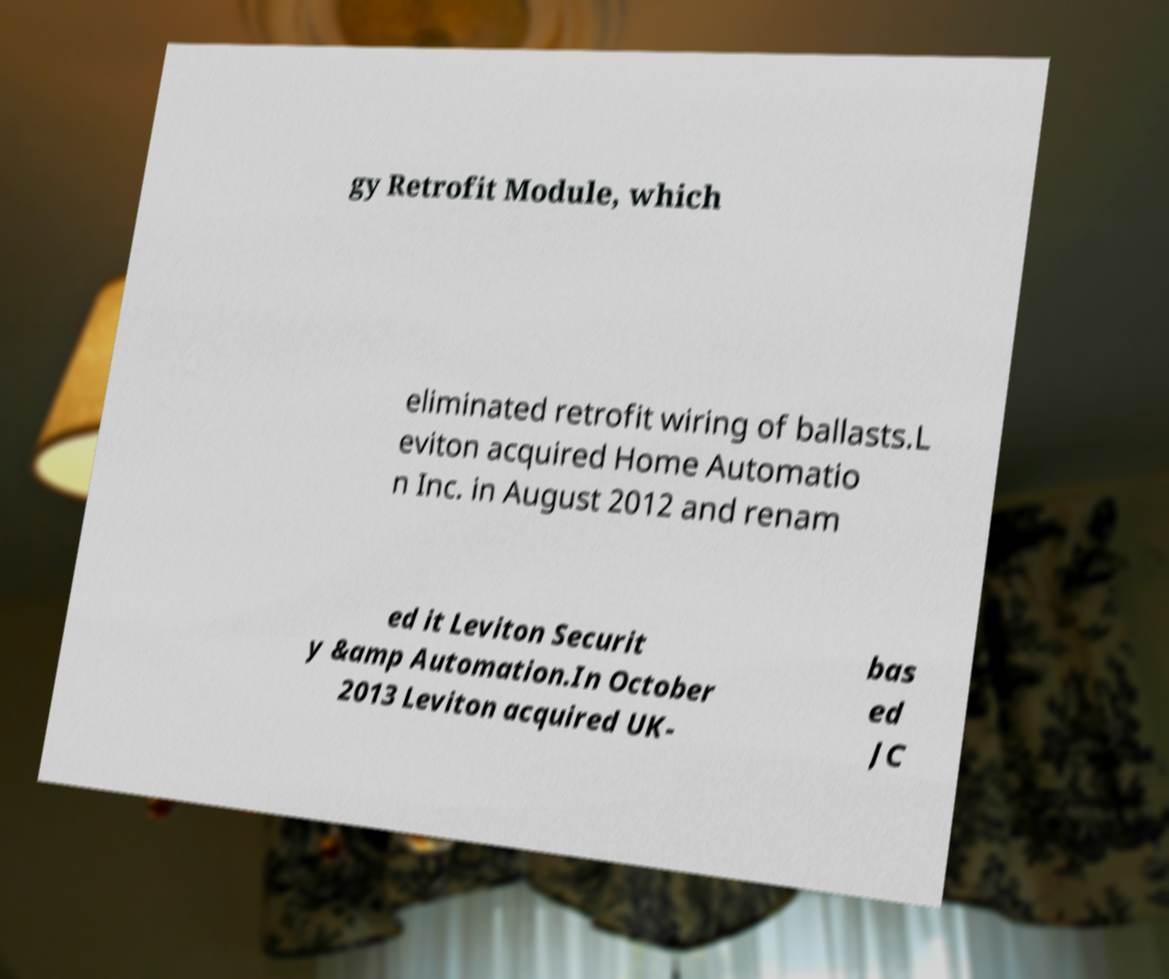Could you extract and type out the text from this image? gy Retrofit Module, which eliminated retrofit wiring of ballasts.L eviton acquired Home Automatio n Inc. in August 2012 and renam ed it Leviton Securit y &amp Automation.In October 2013 Leviton acquired UK- bas ed JC 